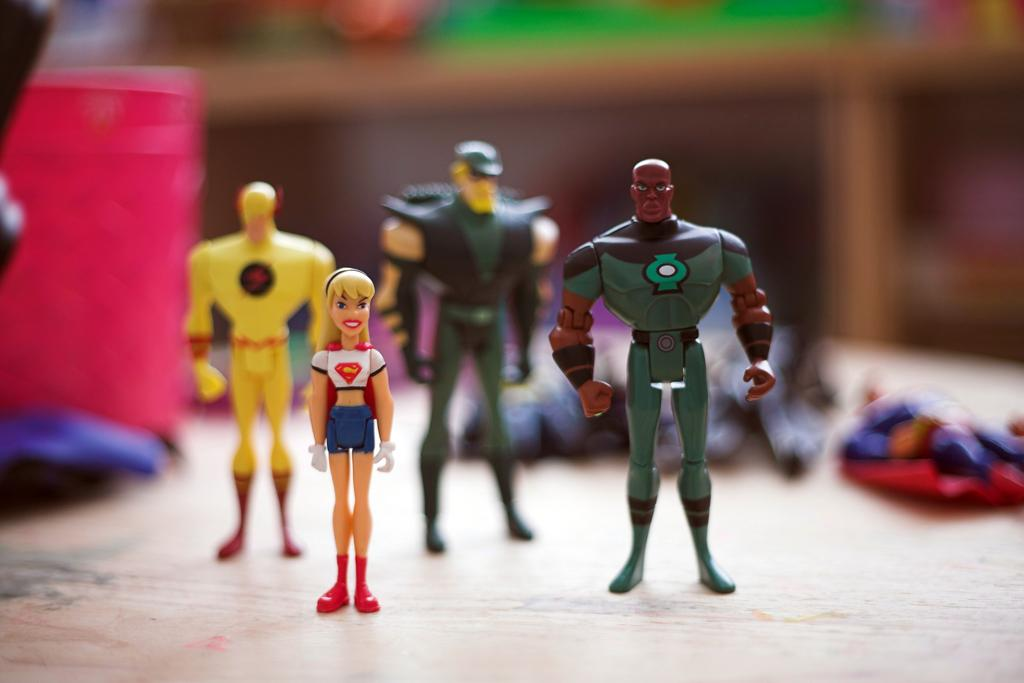What objects are on the table in the image? There are toys on a table in the image. Can you describe the background of the image? The background of the image is blurry. What type of watch is visible on the table in the image? There is no watch present in the image; it only features toys on a table. What is the purpose of the iron in the image? There is no iron present in the image, so it is not possible to determine its purpose. 